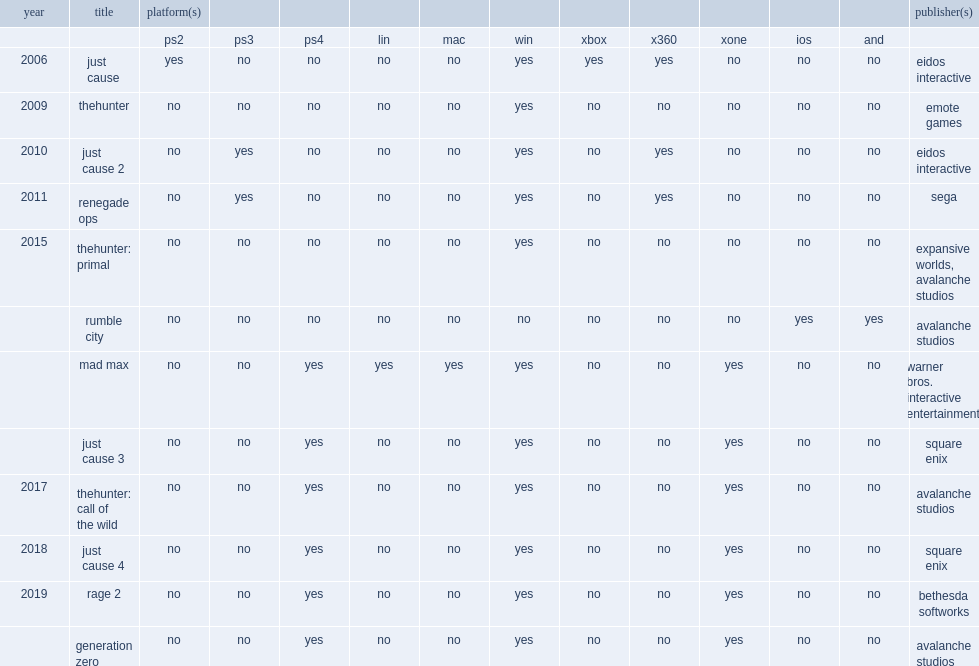Which publisher did generation zero which is a game released in 2019 and self-publish by? Avalanche studios. 